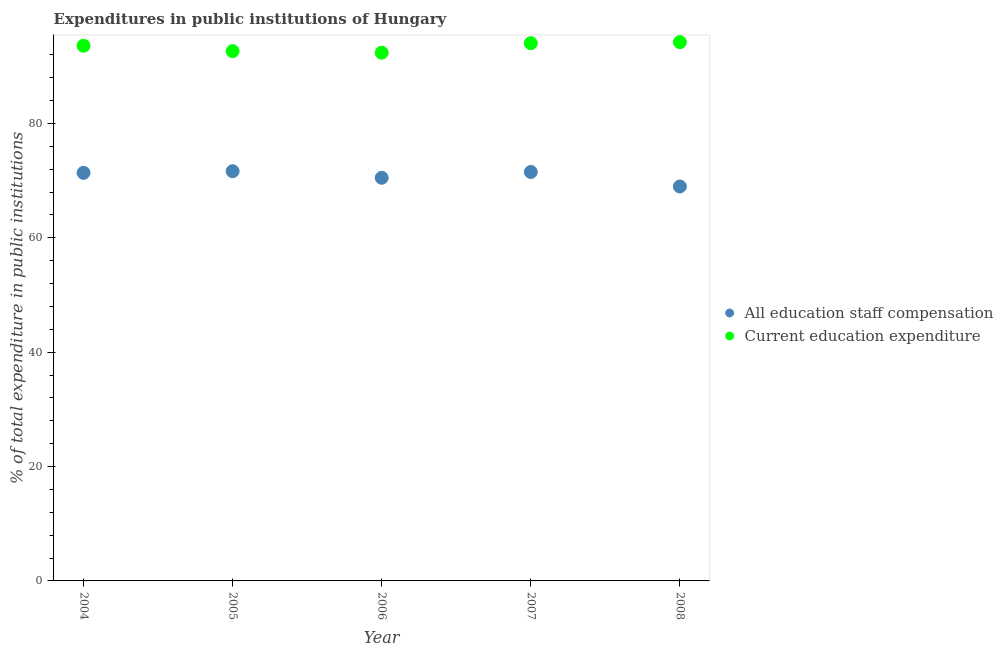How many different coloured dotlines are there?
Ensure brevity in your answer.  2. What is the expenditure in staff compensation in 2007?
Give a very brief answer. 71.51. Across all years, what is the maximum expenditure in staff compensation?
Your answer should be compact. 71.64. Across all years, what is the minimum expenditure in staff compensation?
Make the answer very short. 68.97. In which year was the expenditure in staff compensation maximum?
Provide a short and direct response. 2005. What is the total expenditure in staff compensation in the graph?
Offer a terse response. 353.97. What is the difference between the expenditure in staff compensation in 2006 and that in 2008?
Your answer should be compact. 1.52. What is the difference between the expenditure in education in 2005 and the expenditure in staff compensation in 2008?
Your answer should be very brief. 23.67. What is the average expenditure in staff compensation per year?
Give a very brief answer. 70.79. In the year 2007, what is the difference between the expenditure in staff compensation and expenditure in education?
Keep it short and to the point. -22.52. What is the ratio of the expenditure in education in 2004 to that in 2007?
Give a very brief answer. 1. Is the difference between the expenditure in staff compensation in 2004 and 2008 greater than the difference between the expenditure in education in 2004 and 2008?
Your response must be concise. Yes. What is the difference between the highest and the second highest expenditure in staff compensation?
Provide a succinct answer. 0.13. What is the difference between the highest and the lowest expenditure in staff compensation?
Keep it short and to the point. 2.67. In how many years, is the expenditure in education greater than the average expenditure in education taken over all years?
Your answer should be compact. 3. Is the sum of the expenditure in staff compensation in 2004 and 2008 greater than the maximum expenditure in education across all years?
Give a very brief answer. Yes. Does the expenditure in education monotonically increase over the years?
Ensure brevity in your answer.  No. Is the expenditure in education strictly greater than the expenditure in staff compensation over the years?
Provide a short and direct response. Yes. Is the expenditure in education strictly less than the expenditure in staff compensation over the years?
Make the answer very short. No. How many dotlines are there?
Provide a succinct answer. 2. How many years are there in the graph?
Provide a succinct answer. 5. What is the difference between two consecutive major ticks on the Y-axis?
Give a very brief answer. 20. Are the values on the major ticks of Y-axis written in scientific E-notation?
Offer a terse response. No. Does the graph contain grids?
Provide a short and direct response. No. Where does the legend appear in the graph?
Provide a short and direct response. Center right. How many legend labels are there?
Give a very brief answer. 2. What is the title of the graph?
Your answer should be compact. Expenditures in public institutions of Hungary. What is the label or title of the Y-axis?
Your response must be concise. % of total expenditure in public institutions. What is the % of total expenditure in public institutions of All education staff compensation in 2004?
Offer a terse response. 71.36. What is the % of total expenditure in public institutions of Current education expenditure in 2004?
Your response must be concise. 93.58. What is the % of total expenditure in public institutions in All education staff compensation in 2005?
Make the answer very short. 71.64. What is the % of total expenditure in public institutions in Current education expenditure in 2005?
Make the answer very short. 92.64. What is the % of total expenditure in public institutions of All education staff compensation in 2006?
Your answer should be very brief. 70.49. What is the % of total expenditure in public institutions in Current education expenditure in 2006?
Give a very brief answer. 92.37. What is the % of total expenditure in public institutions of All education staff compensation in 2007?
Ensure brevity in your answer.  71.51. What is the % of total expenditure in public institutions of Current education expenditure in 2007?
Give a very brief answer. 94.03. What is the % of total expenditure in public institutions of All education staff compensation in 2008?
Offer a very short reply. 68.97. What is the % of total expenditure in public institutions in Current education expenditure in 2008?
Keep it short and to the point. 94.22. Across all years, what is the maximum % of total expenditure in public institutions of All education staff compensation?
Offer a very short reply. 71.64. Across all years, what is the maximum % of total expenditure in public institutions of Current education expenditure?
Keep it short and to the point. 94.22. Across all years, what is the minimum % of total expenditure in public institutions in All education staff compensation?
Keep it short and to the point. 68.97. Across all years, what is the minimum % of total expenditure in public institutions in Current education expenditure?
Ensure brevity in your answer.  92.37. What is the total % of total expenditure in public institutions in All education staff compensation in the graph?
Offer a terse response. 353.97. What is the total % of total expenditure in public institutions in Current education expenditure in the graph?
Provide a short and direct response. 466.84. What is the difference between the % of total expenditure in public institutions in All education staff compensation in 2004 and that in 2005?
Your answer should be very brief. -0.29. What is the difference between the % of total expenditure in public institutions of Current education expenditure in 2004 and that in 2005?
Keep it short and to the point. 0.94. What is the difference between the % of total expenditure in public institutions of All education staff compensation in 2004 and that in 2006?
Ensure brevity in your answer.  0.86. What is the difference between the % of total expenditure in public institutions of Current education expenditure in 2004 and that in 2006?
Ensure brevity in your answer.  1.21. What is the difference between the % of total expenditure in public institutions of All education staff compensation in 2004 and that in 2007?
Offer a terse response. -0.15. What is the difference between the % of total expenditure in public institutions of Current education expenditure in 2004 and that in 2007?
Give a very brief answer. -0.45. What is the difference between the % of total expenditure in public institutions in All education staff compensation in 2004 and that in 2008?
Offer a terse response. 2.38. What is the difference between the % of total expenditure in public institutions in Current education expenditure in 2004 and that in 2008?
Give a very brief answer. -0.64. What is the difference between the % of total expenditure in public institutions in All education staff compensation in 2005 and that in 2006?
Provide a succinct answer. 1.15. What is the difference between the % of total expenditure in public institutions of Current education expenditure in 2005 and that in 2006?
Your answer should be compact. 0.26. What is the difference between the % of total expenditure in public institutions of All education staff compensation in 2005 and that in 2007?
Your answer should be very brief. 0.13. What is the difference between the % of total expenditure in public institutions in Current education expenditure in 2005 and that in 2007?
Make the answer very short. -1.39. What is the difference between the % of total expenditure in public institutions of All education staff compensation in 2005 and that in 2008?
Offer a terse response. 2.67. What is the difference between the % of total expenditure in public institutions of Current education expenditure in 2005 and that in 2008?
Make the answer very short. -1.58. What is the difference between the % of total expenditure in public institutions in All education staff compensation in 2006 and that in 2007?
Provide a short and direct response. -1.01. What is the difference between the % of total expenditure in public institutions in Current education expenditure in 2006 and that in 2007?
Offer a terse response. -1.65. What is the difference between the % of total expenditure in public institutions in All education staff compensation in 2006 and that in 2008?
Make the answer very short. 1.52. What is the difference between the % of total expenditure in public institutions of Current education expenditure in 2006 and that in 2008?
Your answer should be very brief. -1.85. What is the difference between the % of total expenditure in public institutions of All education staff compensation in 2007 and that in 2008?
Your answer should be compact. 2.54. What is the difference between the % of total expenditure in public institutions of Current education expenditure in 2007 and that in 2008?
Your answer should be very brief. -0.19. What is the difference between the % of total expenditure in public institutions in All education staff compensation in 2004 and the % of total expenditure in public institutions in Current education expenditure in 2005?
Offer a very short reply. -21.28. What is the difference between the % of total expenditure in public institutions of All education staff compensation in 2004 and the % of total expenditure in public institutions of Current education expenditure in 2006?
Provide a short and direct response. -21.02. What is the difference between the % of total expenditure in public institutions of All education staff compensation in 2004 and the % of total expenditure in public institutions of Current education expenditure in 2007?
Keep it short and to the point. -22.67. What is the difference between the % of total expenditure in public institutions of All education staff compensation in 2004 and the % of total expenditure in public institutions of Current education expenditure in 2008?
Make the answer very short. -22.86. What is the difference between the % of total expenditure in public institutions of All education staff compensation in 2005 and the % of total expenditure in public institutions of Current education expenditure in 2006?
Make the answer very short. -20.73. What is the difference between the % of total expenditure in public institutions of All education staff compensation in 2005 and the % of total expenditure in public institutions of Current education expenditure in 2007?
Provide a succinct answer. -22.39. What is the difference between the % of total expenditure in public institutions of All education staff compensation in 2005 and the % of total expenditure in public institutions of Current education expenditure in 2008?
Make the answer very short. -22.58. What is the difference between the % of total expenditure in public institutions in All education staff compensation in 2006 and the % of total expenditure in public institutions in Current education expenditure in 2007?
Keep it short and to the point. -23.53. What is the difference between the % of total expenditure in public institutions in All education staff compensation in 2006 and the % of total expenditure in public institutions in Current education expenditure in 2008?
Give a very brief answer. -23.73. What is the difference between the % of total expenditure in public institutions in All education staff compensation in 2007 and the % of total expenditure in public institutions in Current education expenditure in 2008?
Your response must be concise. -22.71. What is the average % of total expenditure in public institutions of All education staff compensation per year?
Offer a very short reply. 70.79. What is the average % of total expenditure in public institutions of Current education expenditure per year?
Provide a short and direct response. 93.37. In the year 2004, what is the difference between the % of total expenditure in public institutions of All education staff compensation and % of total expenditure in public institutions of Current education expenditure?
Your answer should be very brief. -22.23. In the year 2005, what is the difference between the % of total expenditure in public institutions in All education staff compensation and % of total expenditure in public institutions in Current education expenditure?
Offer a terse response. -20.99. In the year 2006, what is the difference between the % of total expenditure in public institutions of All education staff compensation and % of total expenditure in public institutions of Current education expenditure?
Provide a short and direct response. -21.88. In the year 2007, what is the difference between the % of total expenditure in public institutions of All education staff compensation and % of total expenditure in public institutions of Current education expenditure?
Keep it short and to the point. -22.52. In the year 2008, what is the difference between the % of total expenditure in public institutions in All education staff compensation and % of total expenditure in public institutions in Current education expenditure?
Provide a short and direct response. -25.25. What is the ratio of the % of total expenditure in public institutions in All education staff compensation in 2004 to that in 2005?
Offer a terse response. 1. What is the ratio of the % of total expenditure in public institutions in Current education expenditure in 2004 to that in 2005?
Make the answer very short. 1.01. What is the ratio of the % of total expenditure in public institutions in All education staff compensation in 2004 to that in 2006?
Offer a very short reply. 1.01. What is the ratio of the % of total expenditure in public institutions of Current education expenditure in 2004 to that in 2006?
Give a very brief answer. 1.01. What is the ratio of the % of total expenditure in public institutions in All education staff compensation in 2004 to that in 2007?
Your answer should be very brief. 1. What is the ratio of the % of total expenditure in public institutions of Current education expenditure in 2004 to that in 2007?
Your response must be concise. 1. What is the ratio of the % of total expenditure in public institutions of All education staff compensation in 2004 to that in 2008?
Give a very brief answer. 1.03. What is the ratio of the % of total expenditure in public institutions in Current education expenditure in 2004 to that in 2008?
Provide a short and direct response. 0.99. What is the ratio of the % of total expenditure in public institutions in All education staff compensation in 2005 to that in 2006?
Your response must be concise. 1.02. What is the ratio of the % of total expenditure in public institutions in Current education expenditure in 2005 to that in 2006?
Keep it short and to the point. 1. What is the ratio of the % of total expenditure in public institutions of Current education expenditure in 2005 to that in 2007?
Ensure brevity in your answer.  0.99. What is the ratio of the % of total expenditure in public institutions in All education staff compensation in 2005 to that in 2008?
Make the answer very short. 1.04. What is the ratio of the % of total expenditure in public institutions in Current education expenditure in 2005 to that in 2008?
Provide a short and direct response. 0.98. What is the ratio of the % of total expenditure in public institutions of All education staff compensation in 2006 to that in 2007?
Give a very brief answer. 0.99. What is the ratio of the % of total expenditure in public institutions of Current education expenditure in 2006 to that in 2007?
Offer a very short reply. 0.98. What is the ratio of the % of total expenditure in public institutions in All education staff compensation in 2006 to that in 2008?
Offer a very short reply. 1.02. What is the ratio of the % of total expenditure in public institutions in Current education expenditure in 2006 to that in 2008?
Provide a short and direct response. 0.98. What is the ratio of the % of total expenditure in public institutions in All education staff compensation in 2007 to that in 2008?
Give a very brief answer. 1.04. What is the difference between the highest and the second highest % of total expenditure in public institutions in All education staff compensation?
Keep it short and to the point. 0.13. What is the difference between the highest and the second highest % of total expenditure in public institutions in Current education expenditure?
Keep it short and to the point. 0.19. What is the difference between the highest and the lowest % of total expenditure in public institutions of All education staff compensation?
Offer a terse response. 2.67. What is the difference between the highest and the lowest % of total expenditure in public institutions in Current education expenditure?
Your response must be concise. 1.85. 